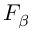Convert formula to latex. <formula><loc_0><loc_0><loc_500><loc_500>F _ { \beta }</formula> 